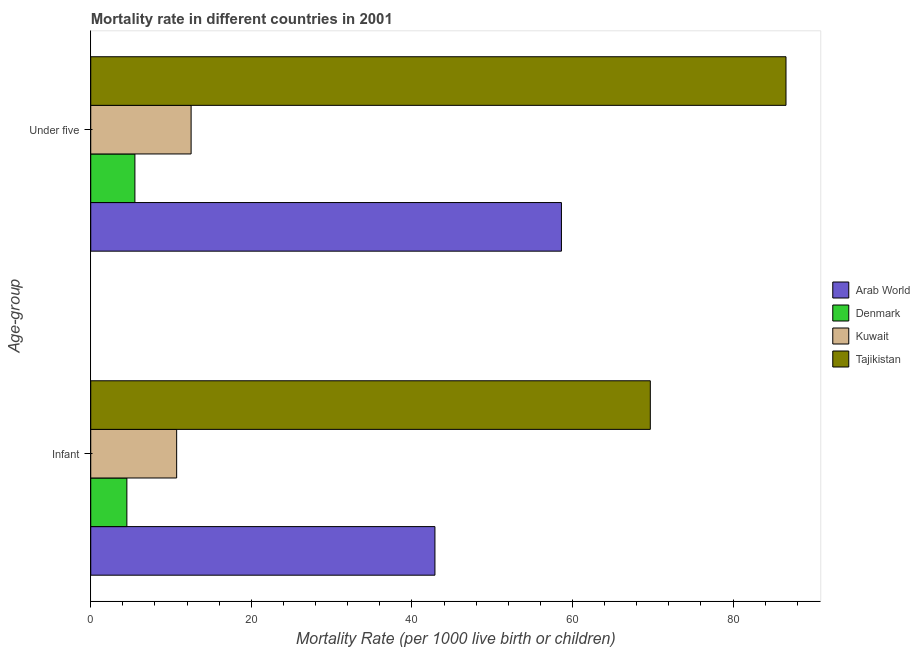How many different coloured bars are there?
Provide a short and direct response. 4. How many bars are there on the 2nd tick from the top?
Your answer should be compact. 4. What is the label of the 2nd group of bars from the top?
Provide a short and direct response. Infant. What is the under-5 mortality rate in Denmark?
Your answer should be compact. 5.5. Across all countries, what is the maximum under-5 mortality rate?
Your answer should be very brief. 86.6. In which country was the under-5 mortality rate maximum?
Give a very brief answer. Tajikistan. What is the total under-5 mortality rate in the graph?
Provide a short and direct response. 163.23. What is the difference between the infant mortality rate in Kuwait and that in Arab World?
Keep it short and to the point. -32.17. What is the difference between the infant mortality rate in Tajikistan and the under-5 mortality rate in Kuwait?
Your response must be concise. 57.2. What is the average under-5 mortality rate per country?
Offer a terse response. 40.81. What is the ratio of the under-5 mortality rate in Kuwait to that in Tajikistan?
Your answer should be very brief. 0.14. Is the under-5 mortality rate in Tajikistan less than that in Denmark?
Your answer should be very brief. No. In how many countries, is the under-5 mortality rate greater than the average under-5 mortality rate taken over all countries?
Make the answer very short. 2. What does the 4th bar from the top in Under five represents?
Offer a very short reply. Arab World. What does the 3rd bar from the bottom in Under five represents?
Give a very brief answer. Kuwait. How many countries are there in the graph?
Ensure brevity in your answer.  4. What is the difference between two consecutive major ticks on the X-axis?
Keep it short and to the point. 20. How are the legend labels stacked?
Give a very brief answer. Vertical. What is the title of the graph?
Your response must be concise. Mortality rate in different countries in 2001. Does "Canada" appear as one of the legend labels in the graph?
Keep it short and to the point. No. What is the label or title of the X-axis?
Keep it short and to the point. Mortality Rate (per 1000 live birth or children). What is the label or title of the Y-axis?
Offer a very short reply. Age-group. What is the Mortality Rate (per 1000 live birth or children) of Arab World in Infant?
Give a very brief answer. 42.87. What is the Mortality Rate (per 1000 live birth or children) in Kuwait in Infant?
Ensure brevity in your answer.  10.7. What is the Mortality Rate (per 1000 live birth or children) in Tajikistan in Infant?
Provide a short and direct response. 69.7. What is the Mortality Rate (per 1000 live birth or children) of Arab World in Under five?
Provide a short and direct response. 58.63. What is the Mortality Rate (per 1000 live birth or children) in Tajikistan in Under five?
Your answer should be very brief. 86.6. Across all Age-group, what is the maximum Mortality Rate (per 1000 live birth or children) in Arab World?
Ensure brevity in your answer.  58.63. Across all Age-group, what is the maximum Mortality Rate (per 1000 live birth or children) of Kuwait?
Give a very brief answer. 12.5. Across all Age-group, what is the maximum Mortality Rate (per 1000 live birth or children) of Tajikistan?
Your response must be concise. 86.6. Across all Age-group, what is the minimum Mortality Rate (per 1000 live birth or children) of Arab World?
Provide a short and direct response. 42.87. Across all Age-group, what is the minimum Mortality Rate (per 1000 live birth or children) of Kuwait?
Offer a very short reply. 10.7. Across all Age-group, what is the minimum Mortality Rate (per 1000 live birth or children) of Tajikistan?
Your answer should be very brief. 69.7. What is the total Mortality Rate (per 1000 live birth or children) of Arab World in the graph?
Your answer should be very brief. 101.5. What is the total Mortality Rate (per 1000 live birth or children) of Denmark in the graph?
Keep it short and to the point. 10. What is the total Mortality Rate (per 1000 live birth or children) of Kuwait in the graph?
Your response must be concise. 23.2. What is the total Mortality Rate (per 1000 live birth or children) of Tajikistan in the graph?
Your answer should be very brief. 156.3. What is the difference between the Mortality Rate (per 1000 live birth or children) in Arab World in Infant and that in Under five?
Provide a short and direct response. -15.76. What is the difference between the Mortality Rate (per 1000 live birth or children) in Denmark in Infant and that in Under five?
Offer a very short reply. -1. What is the difference between the Mortality Rate (per 1000 live birth or children) in Kuwait in Infant and that in Under five?
Ensure brevity in your answer.  -1.8. What is the difference between the Mortality Rate (per 1000 live birth or children) in Tajikistan in Infant and that in Under five?
Your answer should be very brief. -16.9. What is the difference between the Mortality Rate (per 1000 live birth or children) of Arab World in Infant and the Mortality Rate (per 1000 live birth or children) of Denmark in Under five?
Your answer should be compact. 37.37. What is the difference between the Mortality Rate (per 1000 live birth or children) of Arab World in Infant and the Mortality Rate (per 1000 live birth or children) of Kuwait in Under five?
Your answer should be very brief. 30.37. What is the difference between the Mortality Rate (per 1000 live birth or children) in Arab World in Infant and the Mortality Rate (per 1000 live birth or children) in Tajikistan in Under five?
Offer a terse response. -43.73. What is the difference between the Mortality Rate (per 1000 live birth or children) in Denmark in Infant and the Mortality Rate (per 1000 live birth or children) in Kuwait in Under five?
Your answer should be compact. -8. What is the difference between the Mortality Rate (per 1000 live birth or children) of Denmark in Infant and the Mortality Rate (per 1000 live birth or children) of Tajikistan in Under five?
Offer a very short reply. -82.1. What is the difference between the Mortality Rate (per 1000 live birth or children) in Kuwait in Infant and the Mortality Rate (per 1000 live birth or children) in Tajikistan in Under five?
Ensure brevity in your answer.  -75.9. What is the average Mortality Rate (per 1000 live birth or children) of Arab World per Age-group?
Provide a short and direct response. 50.75. What is the average Mortality Rate (per 1000 live birth or children) in Kuwait per Age-group?
Keep it short and to the point. 11.6. What is the average Mortality Rate (per 1000 live birth or children) of Tajikistan per Age-group?
Ensure brevity in your answer.  78.15. What is the difference between the Mortality Rate (per 1000 live birth or children) in Arab World and Mortality Rate (per 1000 live birth or children) in Denmark in Infant?
Give a very brief answer. 38.37. What is the difference between the Mortality Rate (per 1000 live birth or children) in Arab World and Mortality Rate (per 1000 live birth or children) in Kuwait in Infant?
Make the answer very short. 32.17. What is the difference between the Mortality Rate (per 1000 live birth or children) of Arab World and Mortality Rate (per 1000 live birth or children) of Tajikistan in Infant?
Your answer should be very brief. -26.83. What is the difference between the Mortality Rate (per 1000 live birth or children) of Denmark and Mortality Rate (per 1000 live birth or children) of Kuwait in Infant?
Give a very brief answer. -6.2. What is the difference between the Mortality Rate (per 1000 live birth or children) in Denmark and Mortality Rate (per 1000 live birth or children) in Tajikistan in Infant?
Your answer should be compact. -65.2. What is the difference between the Mortality Rate (per 1000 live birth or children) of Kuwait and Mortality Rate (per 1000 live birth or children) of Tajikistan in Infant?
Provide a short and direct response. -59. What is the difference between the Mortality Rate (per 1000 live birth or children) of Arab World and Mortality Rate (per 1000 live birth or children) of Denmark in Under five?
Offer a very short reply. 53.13. What is the difference between the Mortality Rate (per 1000 live birth or children) in Arab World and Mortality Rate (per 1000 live birth or children) in Kuwait in Under five?
Provide a short and direct response. 46.13. What is the difference between the Mortality Rate (per 1000 live birth or children) in Arab World and Mortality Rate (per 1000 live birth or children) in Tajikistan in Under five?
Offer a very short reply. -27.97. What is the difference between the Mortality Rate (per 1000 live birth or children) of Denmark and Mortality Rate (per 1000 live birth or children) of Tajikistan in Under five?
Give a very brief answer. -81.1. What is the difference between the Mortality Rate (per 1000 live birth or children) in Kuwait and Mortality Rate (per 1000 live birth or children) in Tajikistan in Under five?
Ensure brevity in your answer.  -74.1. What is the ratio of the Mortality Rate (per 1000 live birth or children) of Arab World in Infant to that in Under five?
Offer a terse response. 0.73. What is the ratio of the Mortality Rate (per 1000 live birth or children) in Denmark in Infant to that in Under five?
Your answer should be compact. 0.82. What is the ratio of the Mortality Rate (per 1000 live birth or children) of Kuwait in Infant to that in Under five?
Ensure brevity in your answer.  0.86. What is the ratio of the Mortality Rate (per 1000 live birth or children) in Tajikistan in Infant to that in Under five?
Offer a terse response. 0.8. What is the difference between the highest and the second highest Mortality Rate (per 1000 live birth or children) in Arab World?
Give a very brief answer. 15.76. What is the difference between the highest and the second highest Mortality Rate (per 1000 live birth or children) in Tajikistan?
Offer a terse response. 16.9. What is the difference between the highest and the lowest Mortality Rate (per 1000 live birth or children) of Arab World?
Keep it short and to the point. 15.76. 